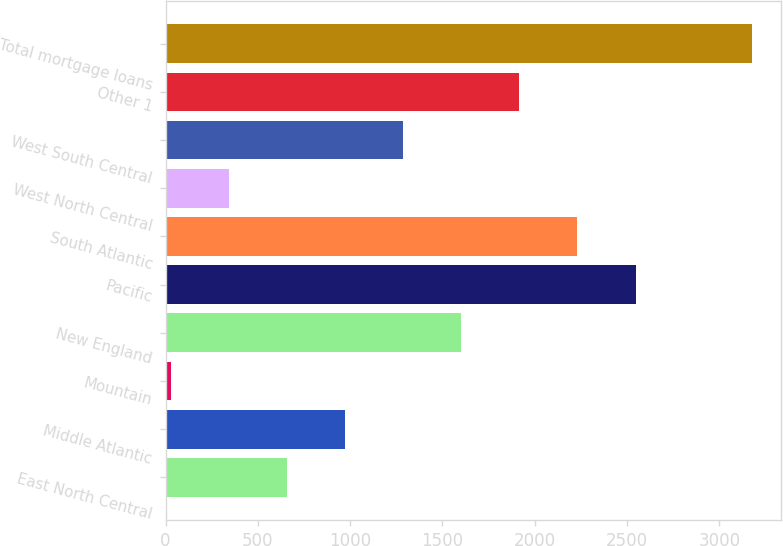<chart> <loc_0><loc_0><loc_500><loc_500><bar_chart><fcel>East North Central<fcel>Middle Atlantic<fcel>Mountain<fcel>New England<fcel>Pacific<fcel>South Atlantic<fcel>West North Central<fcel>West South Central<fcel>Other 1<fcel>Total mortgage loans<nl><fcel>659.8<fcel>974.2<fcel>31<fcel>1603<fcel>2546.2<fcel>2231.8<fcel>345.4<fcel>1288.6<fcel>1917.4<fcel>3175<nl></chart> 